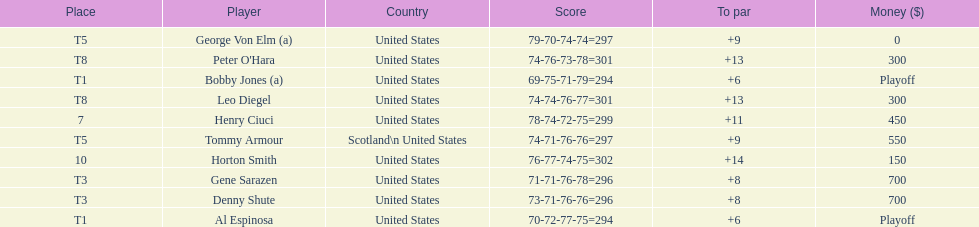Who was the last player in the top 10? Horton Smith. 